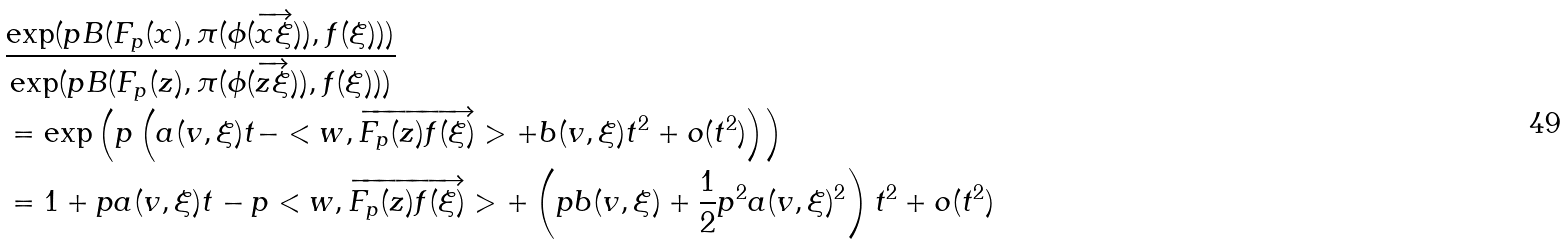Convert formula to latex. <formula><loc_0><loc_0><loc_500><loc_500>& \frac { \exp ( p B ( F _ { p } ( x ) , \pi ( \phi ( \overrightarrow { x \xi } ) ) , f ( \xi ) ) ) } { \exp ( p B ( F _ { p } ( z ) , \pi ( \phi ( \overrightarrow { z \xi } ) ) , f ( \xi ) ) ) } \\ & = \exp \left ( p \left ( a ( v , \xi ) t - < w , \overrightarrow { F _ { p } ( z ) f ( \xi ) } > + b ( v , \xi ) t ^ { 2 } + o ( t ^ { 2 } ) \right ) \right ) \\ & = 1 + p a ( v , \xi ) t - p < w , \overrightarrow { F _ { p } ( z ) f ( \xi ) } > + \left ( p b ( v , \xi ) + \frac { 1 } { 2 } p ^ { 2 } a ( v , \xi ) ^ { 2 } \right ) t ^ { 2 } + o ( t ^ { 2 } ) \\</formula> 